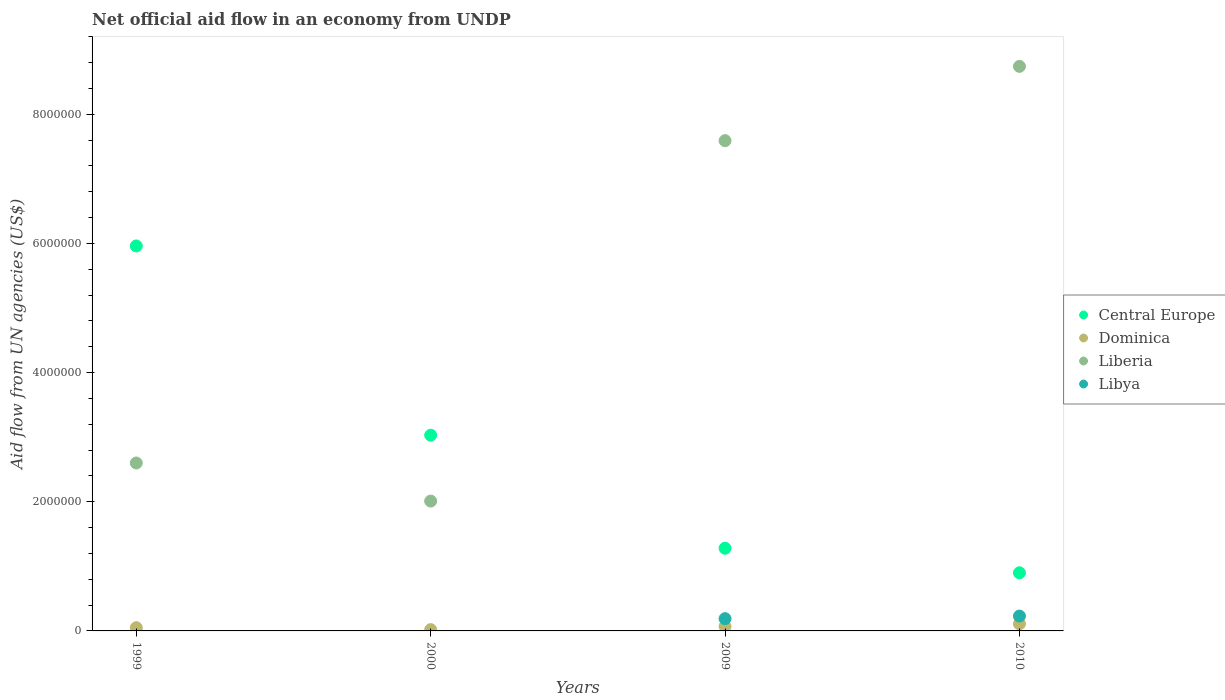How many different coloured dotlines are there?
Your answer should be compact. 4. What is the net official aid flow in Liberia in 2010?
Your response must be concise. 8.74e+06. Across all years, what is the maximum net official aid flow in Dominica?
Ensure brevity in your answer.  1.10e+05. What is the total net official aid flow in Dominica in the graph?
Your answer should be very brief. 2.50e+05. What is the difference between the net official aid flow in Libya in 1999 and the net official aid flow in Dominica in 2009?
Give a very brief answer. -7.00e+04. What is the average net official aid flow in Liberia per year?
Offer a very short reply. 5.24e+06. In the year 2000, what is the difference between the net official aid flow in Liberia and net official aid flow in Dominica?
Your answer should be very brief. 1.99e+06. In how many years, is the net official aid flow in Libya greater than 2000000 US$?
Provide a short and direct response. 0. What is the ratio of the net official aid flow in Central Europe in 1999 to that in 2009?
Provide a short and direct response. 4.66. Is the net official aid flow in Liberia in 2000 less than that in 2010?
Make the answer very short. Yes. What is the difference between the highest and the second highest net official aid flow in Dominica?
Offer a very short reply. 4.00e+04. Is it the case that in every year, the sum of the net official aid flow in Central Europe and net official aid flow in Libya  is greater than the sum of net official aid flow in Dominica and net official aid flow in Liberia?
Offer a terse response. Yes. Is the net official aid flow in Central Europe strictly greater than the net official aid flow in Libya over the years?
Make the answer very short. Yes. How many years are there in the graph?
Your answer should be very brief. 4. Does the graph contain any zero values?
Make the answer very short. Yes. Where does the legend appear in the graph?
Offer a very short reply. Center right. What is the title of the graph?
Offer a very short reply. Net official aid flow in an economy from UNDP. What is the label or title of the X-axis?
Provide a short and direct response. Years. What is the label or title of the Y-axis?
Provide a short and direct response. Aid flow from UN agencies (US$). What is the Aid flow from UN agencies (US$) in Central Europe in 1999?
Provide a short and direct response. 5.96e+06. What is the Aid flow from UN agencies (US$) in Liberia in 1999?
Ensure brevity in your answer.  2.60e+06. What is the Aid flow from UN agencies (US$) in Libya in 1999?
Provide a short and direct response. 0. What is the Aid flow from UN agencies (US$) in Central Europe in 2000?
Ensure brevity in your answer.  3.03e+06. What is the Aid flow from UN agencies (US$) of Liberia in 2000?
Offer a terse response. 2.01e+06. What is the Aid flow from UN agencies (US$) in Libya in 2000?
Give a very brief answer. 0. What is the Aid flow from UN agencies (US$) in Central Europe in 2009?
Give a very brief answer. 1.28e+06. What is the Aid flow from UN agencies (US$) of Dominica in 2009?
Make the answer very short. 7.00e+04. What is the Aid flow from UN agencies (US$) of Liberia in 2009?
Provide a short and direct response. 7.59e+06. What is the Aid flow from UN agencies (US$) of Central Europe in 2010?
Offer a terse response. 9.00e+05. What is the Aid flow from UN agencies (US$) of Liberia in 2010?
Your answer should be very brief. 8.74e+06. What is the Aid flow from UN agencies (US$) of Libya in 2010?
Give a very brief answer. 2.30e+05. Across all years, what is the maximum Aid flow from UN agencies (US$) in Central Europe?
Provide a succinct answer. 5.96e+06. Across all years, what is the maximum Aid flow from UN agencies (US$) in Liberia?
Offer a terse response. 8.74e+06. Across all years, what is the minimum Aid flow from UN agencies (US$) of Dominica?
Offer a very short reply. 2.00e+04. Across all years, what is the minimum Aid flow from UN agencies (US$) of Liberia?
Make the answer very short. 2.01e+06. Across all years, what is the minimum Aid flow from UN agencies (US$) of Libya?
Offer a very short reply. 0. What is the total Aid flow from UN agencies (US$) of Central Europe in the graph?
Your response must be concise. 1.12e+07. What is the total Aid flow from UN agencies (US$) of Liberia in the graph?
Offer a terse response. 2.09e+07. What is the total Aid flow from UN agencies (US$) in Libya in the graph?
Provide a short and direct response. 4.20e+05. What is the difference between the Aid flow from UN agencies (US$) of Central Europe in 1999 and that in 2000?
Offer a terse response. 2.93e+06. What is the difference between the Aid flow from UN agencies (US$) of Liberia in 1999 and that in 2000?
Make the answer very short. 5.90e+05. What is the difference between the Aid flow from UN agencies (US$) in Central Europe in 1999 and that in 2009?
Your response must be concise. 4.68e+06. What is the difference between the Aid flow from UN agencies (US$) of Dominica in 1999 and that in 2009?
Ensure brevity in your answer.  -2.00e+04. What is the difference between the Aid flow from UN agencies (US$) in Liberia in 1999 and that in 2009?
Give a very brief answer. -4.99e+06. What is the difference between the Aid flow from UN agencies (US$) of Central Europe in 1999 and that in 2010?
Your response must be concise. 5.06e+06. What is the difference between the Aid flow from UN agencies (US$) of Dominica in 1999 and that in 2010?
Your answer should be very brief. -6.00e+04. What is the difference between the Aid flow from UN agencies (US$) of Liberia in 1999 and that in 2010?
Offer a terse response. -6.14e+06. What is the difference between the Aid flow from UN agencies (US$) of Central Europe in 2000 and that in 2009?
Keep it short and to the point. 1.75e+06. What is the difference between the Aid flow from UN agencies (US$) in Dominica in 2000 and that in 2009?
Offer a terse response. -5.00e+04. What is the difference between the Aid flow from UN agencies (US$) of Liberia in 2000 and that in 2009?
Offer a terse response. -5.58e+06. What is the difference between the Aid flow from UN agencies (US$) of Central Europe in 2000 and that in 2010?
Make the answer very short. 2.13e+06. What is the difference between the Aid flow from UN agencies (US$) of Liberia in 2000 and that in 2010?
Provide a short and direct response. -6.73e+06. What is the difference between the Aid flow from UN agencies (US$) of Liberia in 2009 and that in 2010?
Give a very brief answer. -1.15e+06. What is the difference between the Aid flow from UN agencies (US$) of Central Europe in 1999 and the Aid flow from UN agencies (US$) of Dominica in 2000?
Offer a terse response. 5.94e+06. What is the difference between the Aid flow from UN agencies (US$) of Central Europe in 1999 and the Aid flow from UN agencies (US$) of Liberia in 2000?
Offer a very short reply. 3.95e+06. What is the difference between the Aid flow from UN agencies (US$) in Dominica in 1999 and the Aid flow from UN agencies (US$) in Liberia in 2000?
Make the answer very short. -1.96e+06. What is the difference between the Aid flow from UN agencies (US$) in Central Europe in 1999 and the Aid flow from UN agencies (US$) in Dominica in 2009?
Your response must be concise. 5.89e+06. What is the difference between the Aid flow from UN agencies (US$) of Central Europe in 1999 and the Aid flow from UN agencies (US$) of Liberia in 2009?
Make the answer very short. -1.63e+06. What is the difference between the Aid flow from UN agencies (US$) of Central Europe in 1999 and the Aid flow from UN agencies (US$) of Libya in 2009?
Give a very brief answer. 5.77e+06. What is the difference between the Aid flow from UN agencies (US$) in Dominica in 1999 and the Aid flow from UN agencies (US$) in Liberia in 2009?
Provide a succinct answer. -7.54e+06. What is the difference between the Aid flow from UN agencies (US$) of Dominica in 1999 and the Aid flow from UN agencies (US$) of Libya in 2009?
Provide a succinct answer. -1.40e+05. What is the difference between the Aid flow from UN agencies (US$) of Liberia in 1999 and the Aid flow from UN agencies (US$) of Libya in 2009?
Offer a very short reply. 2.41e+06. What is the difference between the Aid flow from UN agencies (US$) in Central Europe in 1999 and the Aid flow from UN agencies (US$) in Dominica in 2010?
Keep it short and to the point. 5.85e+06. What is the difference between the Aid flow from UN agencies (US$) in Central Europe in 1999 and the Aid flow from UN agencies (US$) in Liberia in 2010?
Your answer should be compact. -2.78e+06. What is the difference between the Aid flow from UN agencies (US$) of Central Europe in 1999 and the Aid flow from UN agencies (US$) of Libya in 2010?
Provide a succinct answer. 5.73e+06. What is the difference between the Aid flow from UN agencies (US$) in Dominica in 1999 and the Aid flow from UN agencies (US$) in Liberia in 2010?
Keep it short and to the point. -8.69e+06. What is the difference between the Aid flow from UN agencies (US$) in Dominica in 1999 and the Aid flow from UN agencies (US$) in Libya in 2010?
Your answer should be compact. -1.80e+05. What is the difference between the Aid flow from UN agencies (US$) in Liberia in 1999 and the Aid flow from UN agencies (US$) in Libya in 2010?
Keep it short and to the point. 2.37e+06. What is the difference between the Aid flow from UN agencies (US$) in Central Europe in 2000 and the Aid flow from UN agencies (US$) in Dominica in 2009?
Provide a succinct answer. 2.96e+06. What is the difference between the Aid flow from UN agencies (US$) of Central Europe in 2000 and the Aid flow from UN agencies (US$) of Liberia in 2009?
Your answer should be compact. -4.56e+06. What is the difference between the Aid flow from UN agencies (US$) in Central Europe in 2000 and the Aid flow from UN agencies (US$) in Libya in 2009?
Give a very brief answer. 2.84e+06. What is the difference between the Aid flow from UN agencies (US$) in Dominica in 2000 and the Aid flow from UN agencies (US$) in Liberia in 2009?
Give a very brief answer. -7.57e+06. What is the difference between the Aid flow from UN agencies (US$) in Liberia in 2000 and the Aid flow from UN agencies (US$) in Libya in 2009?
Offer a terse response. 1.82e+06. What is the difference between the Aid flow from UN agencies (US$) of Central Europe in 2000 and the Aid flow from UN agencies (US$) of Dominica in 2010?
Your answer should be very brief. 2.92e+06. What is the difference between the Aid flow from UN agencies (US$) of Central Europe in 2000 and the Aid flow from UN agencies (US$) of Liberia in 2010?
Your answer should be very brief. -5.71e+06. What is the difference between the Aid flow from UN agencies (US$) in Central Europe in 2000 and the Aid flow from UN agencies (US$) in Libya in 2010?
Keep it short and to the point. 2.80e+06. What is the difference between the Aid flow from UN agencies (US$) of Dominica in 2000 and the Aid flow from UN agencies (US$) of Liberia in 2010?
Ensure brevity in your answer.  -8.72e+06. What is the difference between the Aid flow from UN agencies (US$) in Dominica in 2000 and the Aid flow from UN agencies (US$) in Libya in 2010?
Make the answer very short. -2.10e+05. What is the difference between the Aid flow from UN agencies (US$) of Liberia in 2000 and the Aid flow from UN agencies (US$) of Libya in 2010?
Your answer should be compact. 1.78e+06. What is the difference between the Aid flow from UN agencies (US$) in Central Europe in 2009 and the Aid flow from UN agencies (US$) in Dominica in 2010?
Offer a very short reply. 1.17e+06. What is the difference between the Aid flow from UN agencies (US$) of Central Europe in 2009 and the Aid flow from UN agencies (US$) of Liberia in 2010?
Offer a terse response. -7.46e+06. What is the difference between the Aid flow from UN agencies (US$) in Central Europe in 2009 and the Aid flow from UN agencies (US$) in Libya in 2010?
Provide a succinct answer. 1.05e+06. What is the difference between the Aid flow from UN agencies (US$) of Dominica in 2009 and the Aid flow from UN agencies (US$) of Liberia in 2010?
Provide a succinct answer. -8.67e+06. What is the difference between the Aid flow from UN agencies (US$) in Liberia in 2009 and the Aid flow from UN agencies (US$) in Libya in 2010?
Keep it short and to the point. 7.36e+06. What is the average Aid flow from UN agencies (US$) in Central Europe per year?
Offer a terse response. 2.79e+06. What is the average Aid flow from UN agencies (US$) of Dominica per year?
Offer a very short reply. 6.25e+04. What is the average Aid flow from UN agencies (US$) of Liberia per year?
Your answer should be compact. 5.24e+06. What is the average Aid flow from UN agencies (US$) in Libya per year?
Offer a terse response. 1.05e+05. In the year 1999, what is the difference between the Aid flow from UN agencies (US$) in Central Europe and Aid flow from UN agencies (US$) in Dominica?
Give a very brief answer. 5.91e+06. In the year 1999, what is the difference between the Aid flow from UN agencies (US$) in Central Europe and Aid flow from UN agencies (US$) in Liberia?
Give a very brief answer. 3.36e+06. In the year 1999, what is the difference between the Aid flow from UN agencies (US$) in Dominica and Aid flow from UN agencies (US$) in Liberia?
Keep it short and to the point. -2.55e+06. In the year 2000, what is the difference between the Aid flow from UN agencies (US$) in Central Europe and Aid flow from UN agencies (US$) in Dominica?
Keep it short and to the point. 3.01e+06. In the year 2000, what is the difference between the Aid flow from UN agencies (US$) in Central Europe and Aid flow from UN agencies (US$) in Liberia?
Provide a succinct answer. 1.02e+06. In the year 2000, what is the difference between the Aid flow from UN agencies (US$) of Dominica and Aid flow from UN agencies (US$) of Liberia?
Offer a very short reply. -1.99e+06. In the year 2009, what is the difference between the Aid flow from UN agencies (US$) of Central Europe and Aid flow from UN agencies (US$) of Dominica?
Make the answer very short. 1.21e+06. In the year 2009, what is the difference between the Aid flow from UN agencies (US$) of Central Europe and Aid flow from UN agencies (US$) of Liberia?
Offer a very short reply. -6.31e+06. In the year 2009, what is the difference between the Aid flow from UN agencies (US$) in Central Europe and Aid flow from UN agencies (US$) in Libya?
Ensure brevity in your answer.  1.09e+06. In the year 2009, what is the difference between the Aid flow from UN agencies (US$) in Dominica and Aid flow from UN agencies (US$) in Liberia?
Make the answer very short. -7.52e+06. In the year 2009, what is the difference between the Aid flow from UN agencies (US$) in Liberia and Aid flow from UN agencies (US$) in Libya?
Offer a very short reply. 7.40e+06. In the year 2010, what is the difference between the Aid flow from UN agencies (US$) of Central Europe and Aid flow from UN agencies (US$) of Dominica?
Offer a terse response. 7.90e+05. In the year 2010, what is the difference between the Aid flow from UN agencies (US$) in Central Europe and Aid flow from UN agencies (US$) in Liberia?
Your response must be concise. -7.84e+06. In the year 2010, what is the difference between the Aid flow from UN agencies (US$) of Central Europe and Aid flow from UN agencies (US$) of Libya?
Provide a short and direct response. 6.70e+05. In the year 2010, what is the difference between the Aid flow from UN agencies (US$) in Dominica and Aid flow from UN agencies (US$) in Liberia?
Your answer should be very brief. -8.63e+06. In the year 2010, what is the difference between the Aid flow from UN agencies (US$) in Liberia and Aid flow from UN agencies (US$) in Libya?
Provide a short and direct response. 8.51e+06. What is the ratio of the Aid flow from UN agencies (US$) of Central Europe in 1999 to that in 2000?
Give a very brief answer. 1.97. What is the ratio of the Aid flow from UN agencies (US$) in Liberia in 1999 to that in 2000?
Make the answer very short. 1.29. What is the ratio of the Aid flow from UN agencies (US$) in Central Europe in 1999 to that in 2009?
Provide a succinct answer. 4.66. What is the ratio of the Aid flow from UN agencies (US$) of Dominica in 1999 to that in 2009?
Your answer should be compact. 0.71. What is the ratio of the Aid flow from UN agencies (US$) in Liberia in 1999 to that in 2009?
Offer a very short reply. 0.34. What is the ratio of the Aid flow from UN agencies (US$) in Central Europe in 1999 to that in 2010?
Keep it short and to the point. 6.62. What is the ratio of the Aid flow from UN agencies (US$) in Dominica in 1999 to that in 2010?
Your answer should be compact. 0.45. What is the ratio of the Aid flow from UN agencies (US$) of Liberia in 1999 to that in 2010?
Your response must be concise. 0.3. What is the ratio of the Aid flow from UN agencies (US$) in Central Europe in 2000 to that in 2009?
Give a very brief answer. 2.37. What is the ratio of the Aid flow from UN agencies (US$) in Dominica in 2000 to that in 2009?
Provide a short and direct response. 0.29. What is the ratio of the Aid flow from UN agencies (US$) of Liberia in 2000 to that in 2009?
Provide a short and direct response. 0.26. What is the ratio of the Aid flow from UN agencies (US$) in Central Europe in 2000 to that in 2010?
Provide a short and direct response. 3.37. What is the ratio of the Aid flow from UN agencies (US$) in Dominica in 2000 to that in 2010?
Make the answer very short. 0.18. What is the ratio of the Aid flow from UN agencies (US$) of Liberia in 2000 to that in 2010?
Your response must be concise. 0.23. What is the ratio of the Aid flow from UN agencies (US$) of Central Europe in 2009 to that in 2010?
Your answer should be compact. 1.42. What is the ratio of the Aid flow from UN agencies (US$) in Dominica in 2009 to that in 2010?
Offer a terse response. 0.64. What is the ratio of the Aid flow from UN agencies (US$) of Liberia in 2009 to that in 2010?
Offer a terse response. 0.87. What is the ratio of the Aid flow from UN agencies (US$) in Libya in 2009 to that in 2010?
Provide a short and direct response. 0.83. What is the difference between the highest and the second highest Aid flow from UN agencies (US$) in Central Europe?
Make the answer very short. 2.93e+06. What is the difference between the highest and the second highest Aid flow from UN agencies (US$) in Dominica?
Offer a very short reply. 4.00e+04. What is the difference between the highest and the second highest Aid flow from UN agencies (US$) in Liberia?
Your response must be concise. 1.15e+06. What is the difference between the highest and the lowest Aid flow from UN agencies (US$) of Central Europe?
Give a very brief answer. 5.06e+06. What is the difference between the highest and the lowest Aid flow from UN agencies (US$) of Dominica?
Give a very brief answer. 9.00e+04. What is the difference between the highest and the lowest Aid flow from UN agencies (US$) in Liberia?
Ensure brevity in your answer.  6.73e+06. 